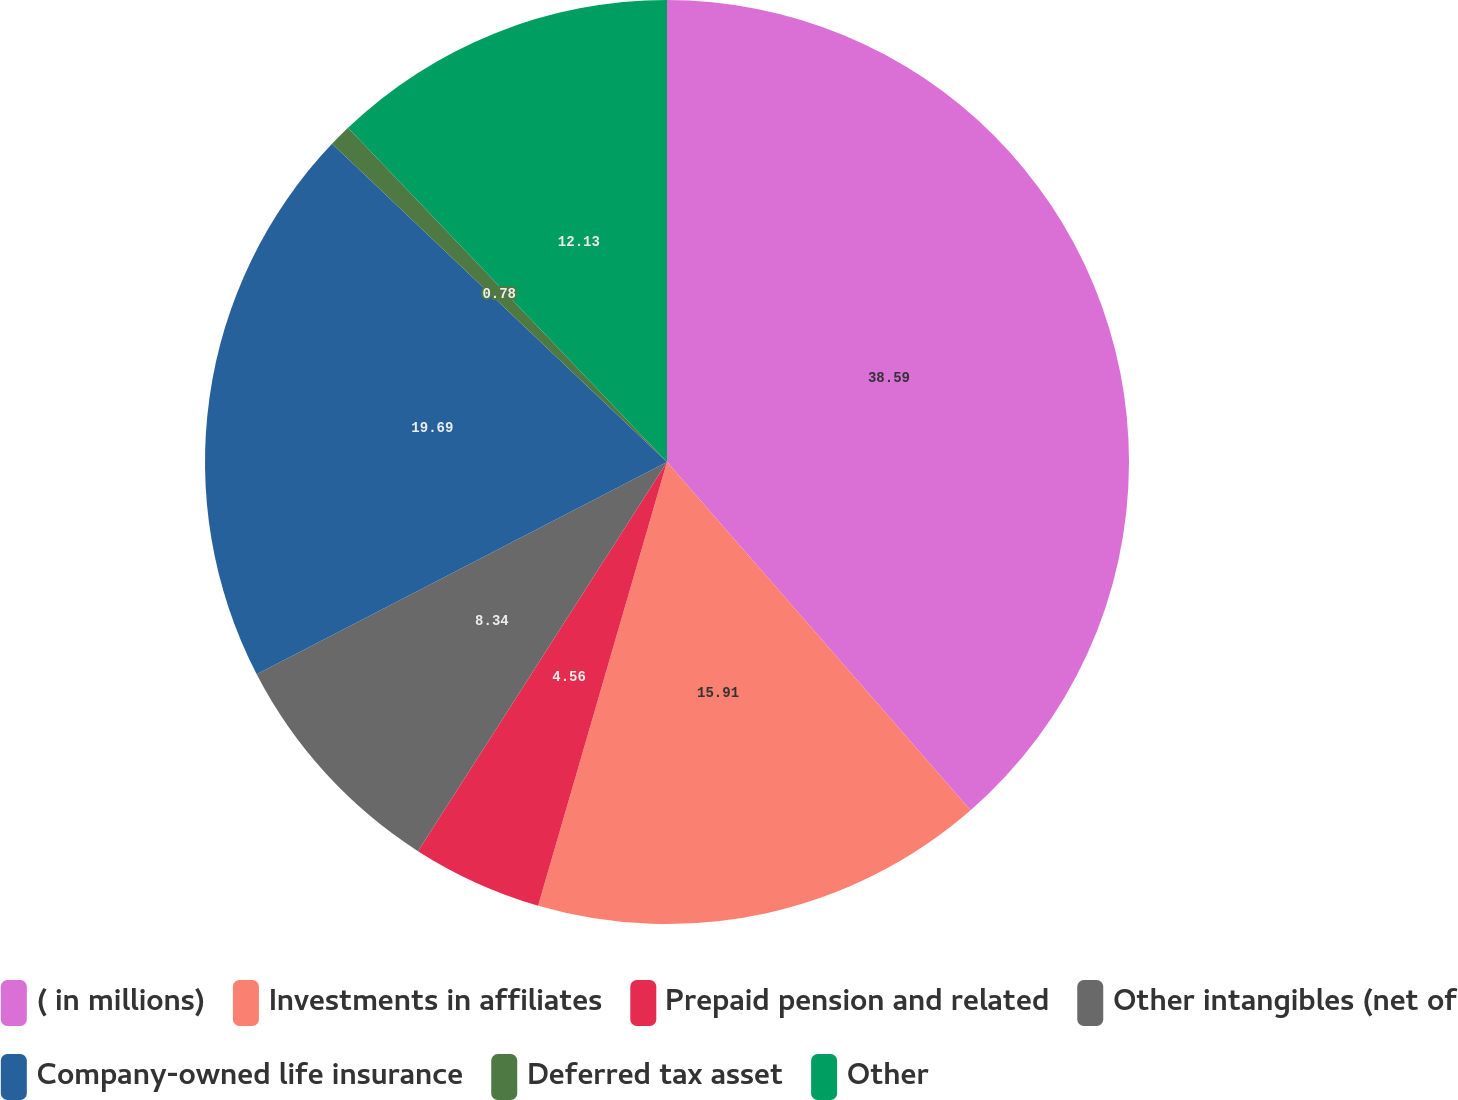<chart> <loc_0><loc_0><loc_500><loc_500><pie_chart><fcel>( in millions)<fcel>Investments in affiliates<fcel>Prepaid pension and related<fcel>Other intangibles (net of<fcel>Company-owned life insurance<fcel>Deferred tax asset<fcel>Other<nl><fcel>38.59%<fcel>15.91%<fcel>4.56%<fcel>8.34%<fcel>19.69%<fcel>0.78%<fcel>12.13%<nl></chart> 